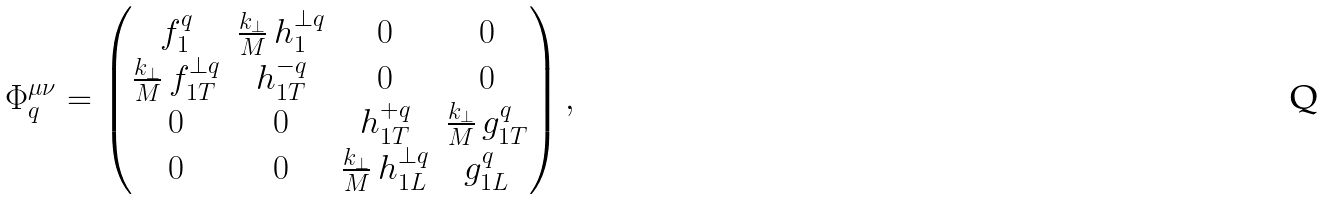Convert formula to latex. <formula><loc_0><loc_0><loc_500><loc_500>\Phi ^ { \mu \nu } _ { q } = \begin{pmatrix} f ^ { q } _ { 1 } & \frac { k _ { \perp } } { M } \, h _ { 1 } ^ { \perp q } & 0 & 0 \\ \frac { k _ { \perp } } { M } \, f _ { 1 T } ^ { \perp q } & h _ { 1 T } ^ { - q } & 0 & 0 \\ 0 & 0 & h _ { 1 T } ^ { + q } & \frac { k _ { \perp } } { M } \, g _ { 1 T } ^ { q } \\ 0 & 0 & \frac { k _ { \perp } } { M } \, h _ { 1 L } ^ { \perp q } & g _ { 1 L } ^ { q } \end{pmatrix} ,</formula> 